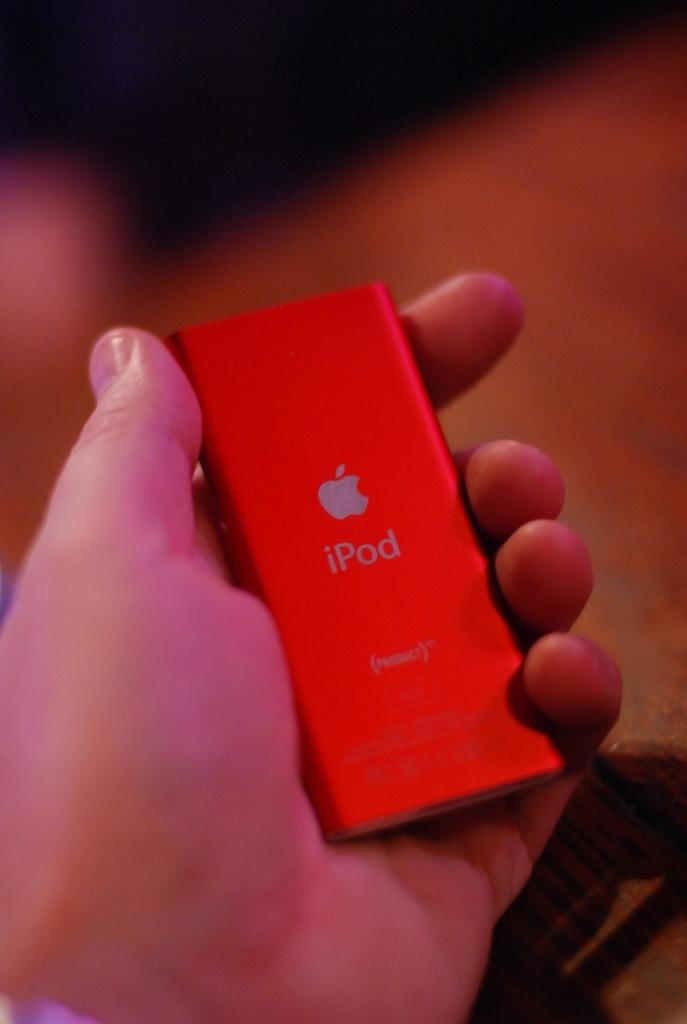<image>
Share a concise interpretation of the image provided. a person holding up a red ipod in their hand 